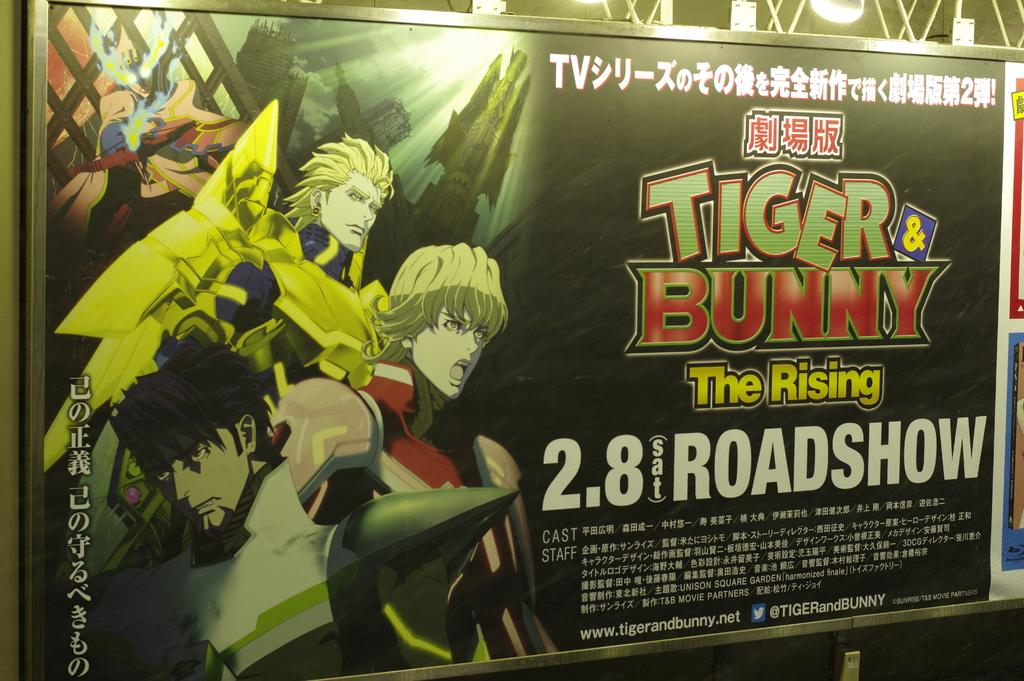<image>
Offer a succinct explanation of the picture presented. Poster for an anime titled "Tiger & Bunny" 